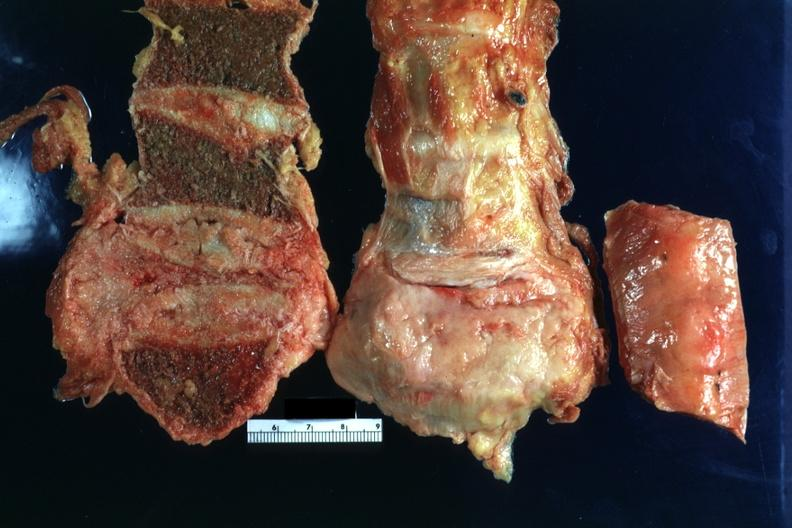what does this image show?
Answer the question using a single word or phrase. Collapsed vertebral body with obvious gray tumor tissue adjacent 